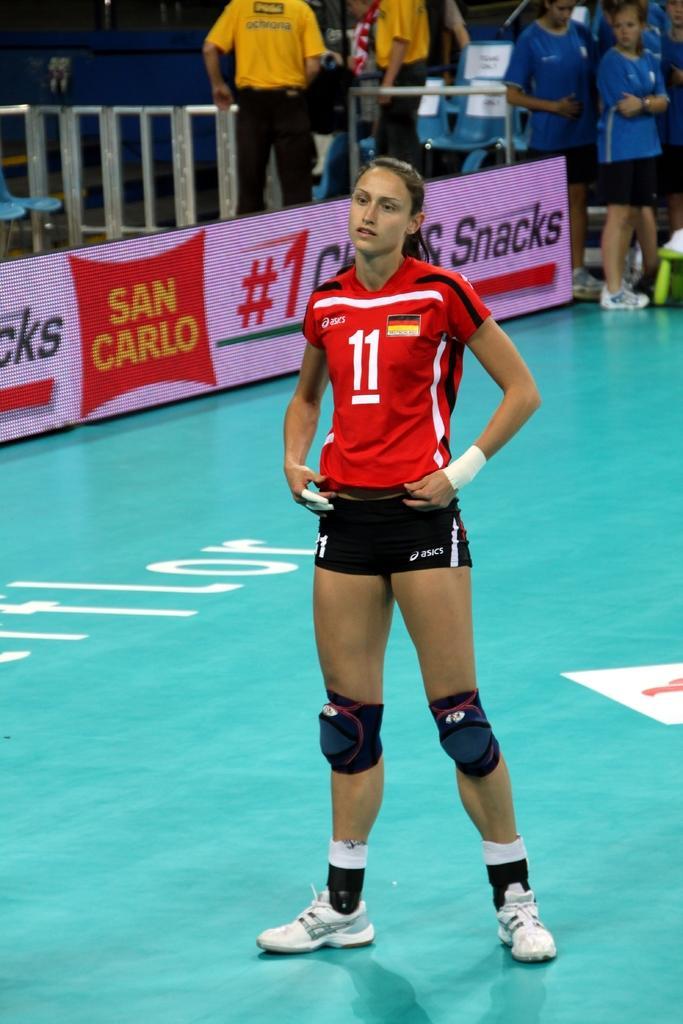In one or two sentences, can you explain what this image depicts? In this picture, we can see a woman in the red t shirt is standing on the path and behind the woman there are boards, group of people are standing and other things. 